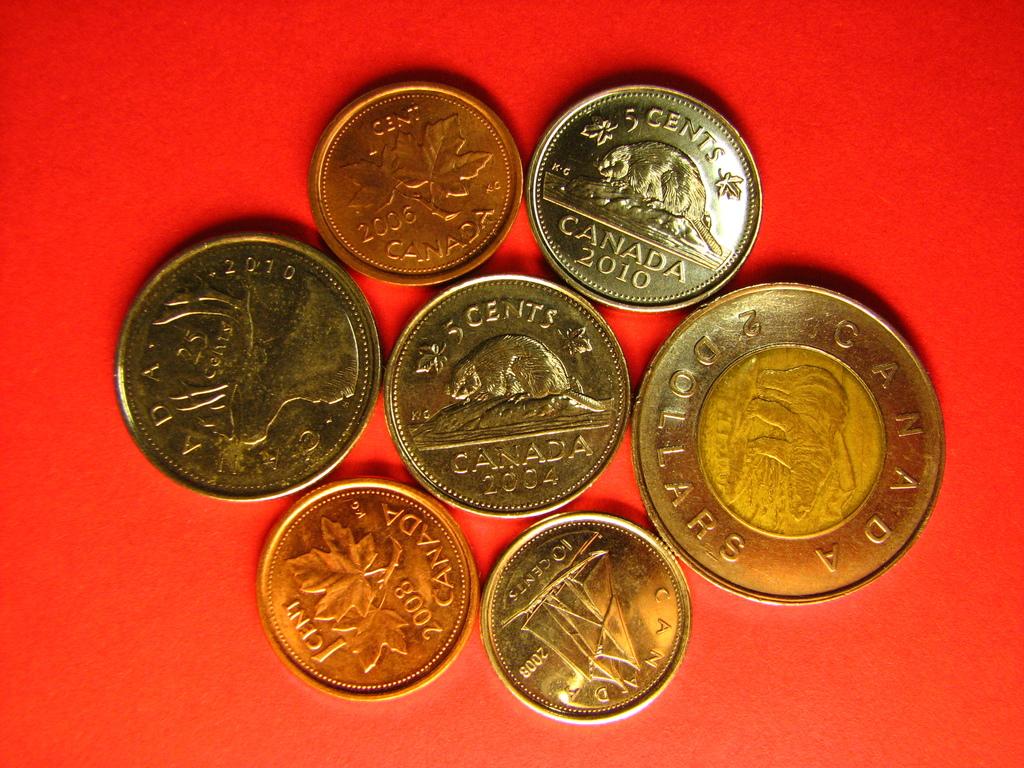What country are the coins from?
Give a very brief answer. Canada. What currency are the coins?
Ensure brevity in your answer.  Canadian. 